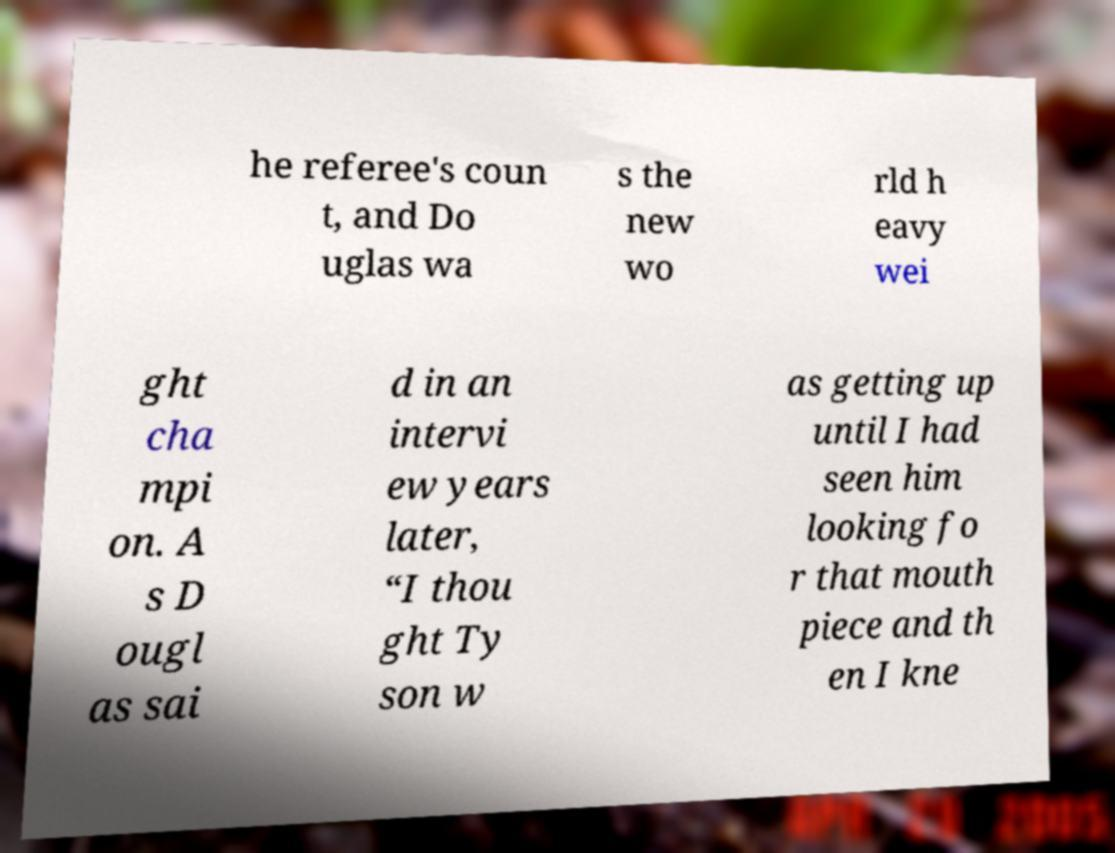Please identify and transcribe the text found in this image. he referee's coun t, and Do uglas wa s the new wo rld h eavy wei ght cha mpi on. A s D ougl as sai d in an intervi ew years later, “I thou ght Ty son w as getting up until I had seen him looking fo r that mouth piece and th en I kne 